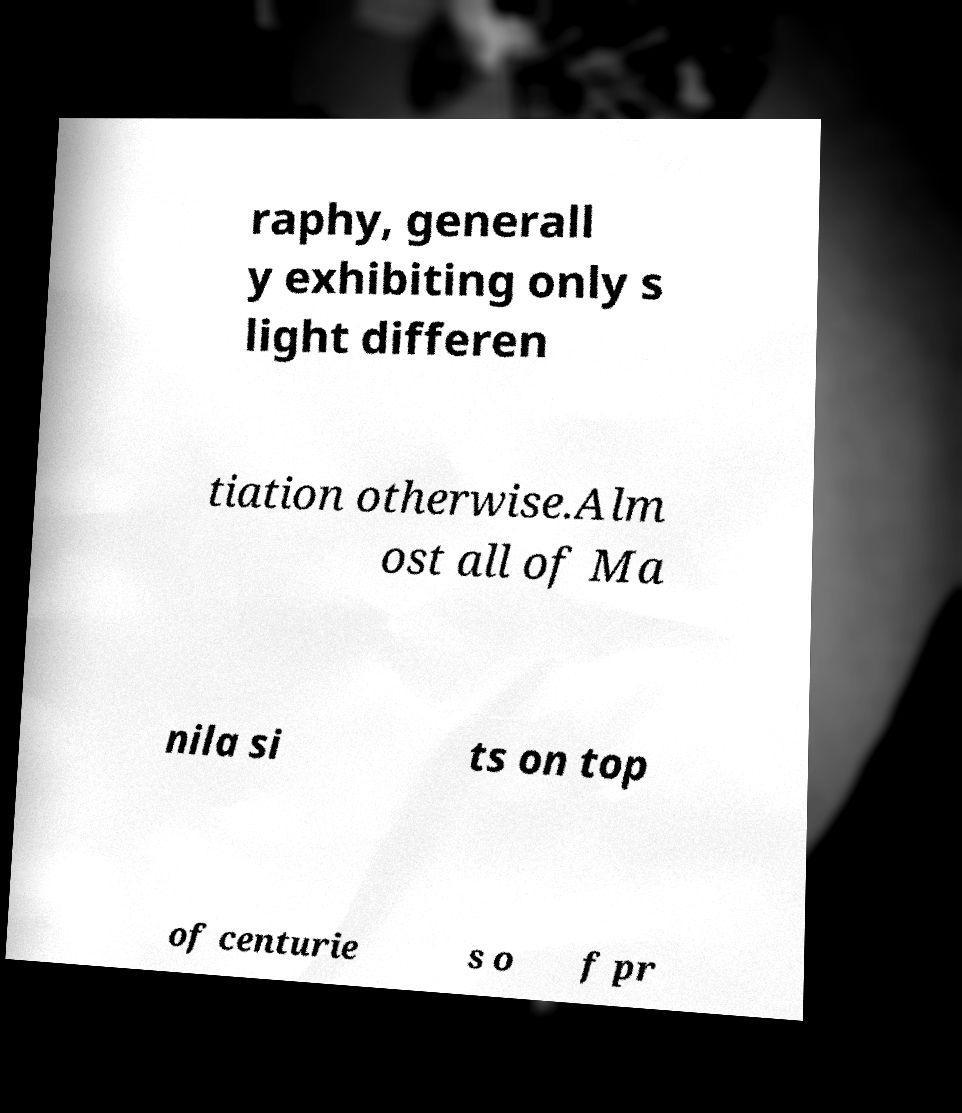Can you accurately transcribe the text from the provided image for me? raphy, generall y exhibiting only s light differen tiation otherwise.Alm ost all of Ma nila si ts on top of centurie s o f pr 